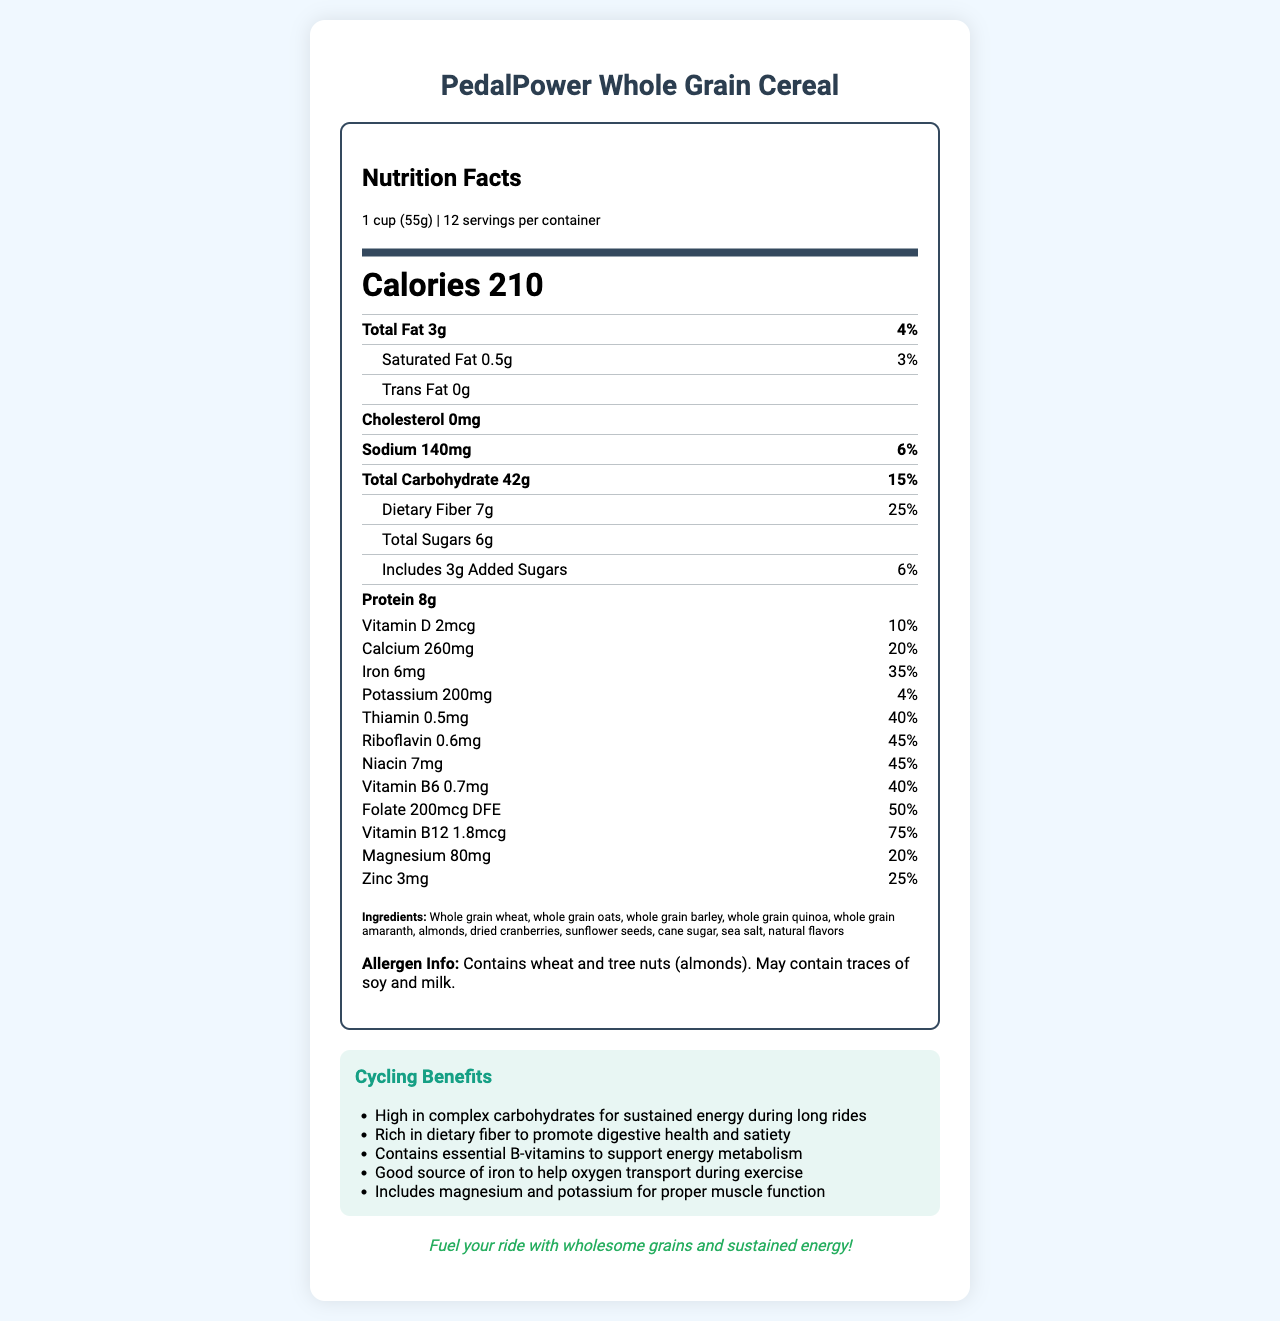which product is being described in this document? The product name "PedalPower Whole Grain Cereal" is prominently displayed at the top of the document.
Answer: PedalPower Whole Grain Cereal how many servings are there per container? The document specifies that there are 12 servings per container in the serving information section.
Answer: 12 what is the amount of dietary fiber per serving? The nutrition label lists dietary fiber as 7g per serving.
Answer: 7g what percentage of the daily value for iron does one serving provide? The document specifies that one serving provides 35% of the daily value for iron.
Answer: 35% which company manufactures this product? The document states that "HealthyRide Nutrition Co." is the manufacturer.
Answer: HealthyRide Nutrition Co. which of the following vitamins has the highest daily value percentage in one serving? A. Vitamin D 10% B. Vitamin B12 75% C. Calcium 20% The document shows that Vitamin B12 has a daily value percentage of 75%, which is higher compared to Vitamin D (10%) and Calcium (20%).
Answer: B. Vitamin B12 75% which nutrient do we get the least amount of from one serving size? I. Trans Fat II. Saturated Fat III. Total Sugars IV. Cholesterol The document lists Trans Fat as 0g, indicating it is the least among the other listed nutrients.
Answer: I. Trans Fat does this cereal contain any cholesterol? The document states that cholesterol content in the cereal is 0mg.
Answer: No does this product contain any allergens? The allergen info section of the document clearly states that it contains wheat and tree nuts (almonds).
Answer: Yes what are the main benefits of this cereal for cyclists? The cycling benefits section lists these specific advantages for cyclists.
Answer: High in complex carbohydrates for sustained energy, rich in dietary fiber, contains essential B-vitamins, good source of iron, includes magnesium and potassium who is this product suitable for? The document talks about the general benefits but does not provide enough information to determine who specifically should consume this product (beyond general cycling enthusiasts).
Answer: Not enough information describe the purpose of the document in one sentence. The document aims to present the nutritional content and cycling-specific benefits of the PedalPower Whole Grain Cereal.
Answer: This document provides the nutrition facts and benefits of PedalPower Whole Grain Cereal, highlighting its suitability as an energy-sustaining food for cyclists. 